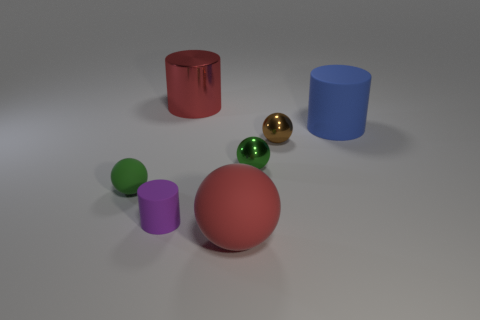There is a blue rubber object that is the same shape as the tiny purple object; what size is it?
Your response must be concise. Large. Are there more purple rubber objects to the right of the large ball than big cylinders that are on the right side of the shiny cylinder?
Your answer should be very brief. No. There is another sphere that is the same color as the tiny rubber sphere; what is its material?
Provide a short and direct response. Metal. What number of small matte cylinders have the same color as the big metal cylinder?
Give a very brief answer. 0. There is a rubber object behind the tiny brown metal thing; does it have the same color as the big cylinder that is on the left side of the tiny brown ball?
Give a very brief answer. No. Are there any small brown balls left of the green rubber thing?
Make the answer very short. No. What material is the small brown sphere?
Your answer should be very brief. Metal. What shape is the shiny object that is in front of the tiny brown sphere?
Ensure brevity in your answer.  Sphere. There is a matte object that is the same color as the large metallic cylinder; what size is it?
Your response must be concise. Large. Is there a ball that has the same size as the red matte object?
Keep it short and to the point. No. 